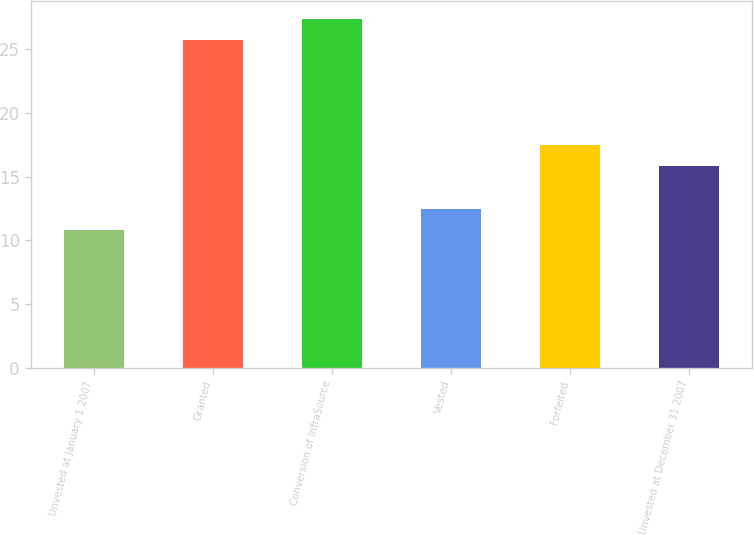Convert chart to OTSL. <chart><loc_0><loc_0><loc_500><loc_500><bar_chart><fcel>Unvested at January 1 2007<fcel>Granted<fcel>Conversion of InfraSource<fcel>Vested<fcel>Forfeited<fcel>Unvested at December 31 2007<nl><fcel>10.85<fcel>25.72<fcel>27.39<fcel>12.5<fcel>17.49<fcel>15.84<nl></chart> 